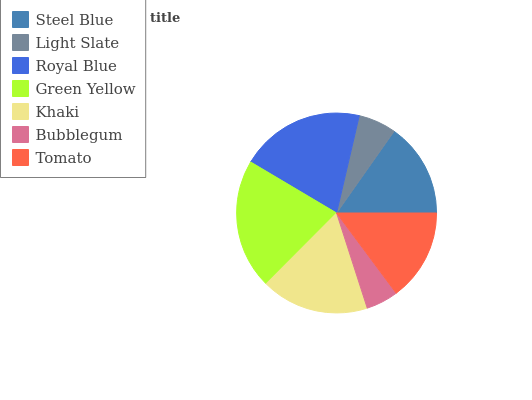Is Bubblegum the minimum?
Answer yes or no. Yes. Is Green Yellow the maximum?
Answer yes or no. Yes. Is Light Slate the minimum?
Answer yes or no. No. Is Light Slate the maximum?
Answer yes or no. No. Is Steel Blue greater than Light Slate?
Answer yes or no. Yes. Is Light Slate less than Steel Blue?
Answer yes or no. Yes. Is Light Slate greater than Steel Blue?
Answer yes or no. No. Is Steel Blue less than Light Slate?
Answer yes or no. No. Is Steel Blue the high median?
Answer yes or no. Yes. Is Steel Blue the low median?
Answer yes or no. Yes. Is Light Slate the high median?
Answer yes or no. No. Is Green Yellow the low median?
Answer yes or no. No. 